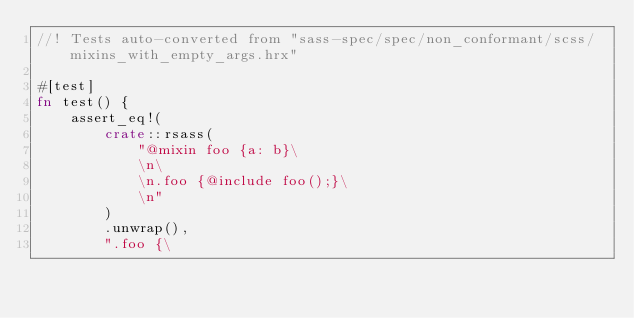<code> <loc_0><loc_0><loc_500><loc_500><_Rust_>//! Tests auto-converted from "sass-spec/spec/non_conformant/scss/mixins_with_empty_args.hrx"

#[test]
fn test() {
    assert_eq!(
        crate::rsass(
            "@mixin foo {a: b}\
            \n\
            \n.foo {@include foo();}\
            \n"
        )
        .unwrap(),
        ".foo {\</code> 